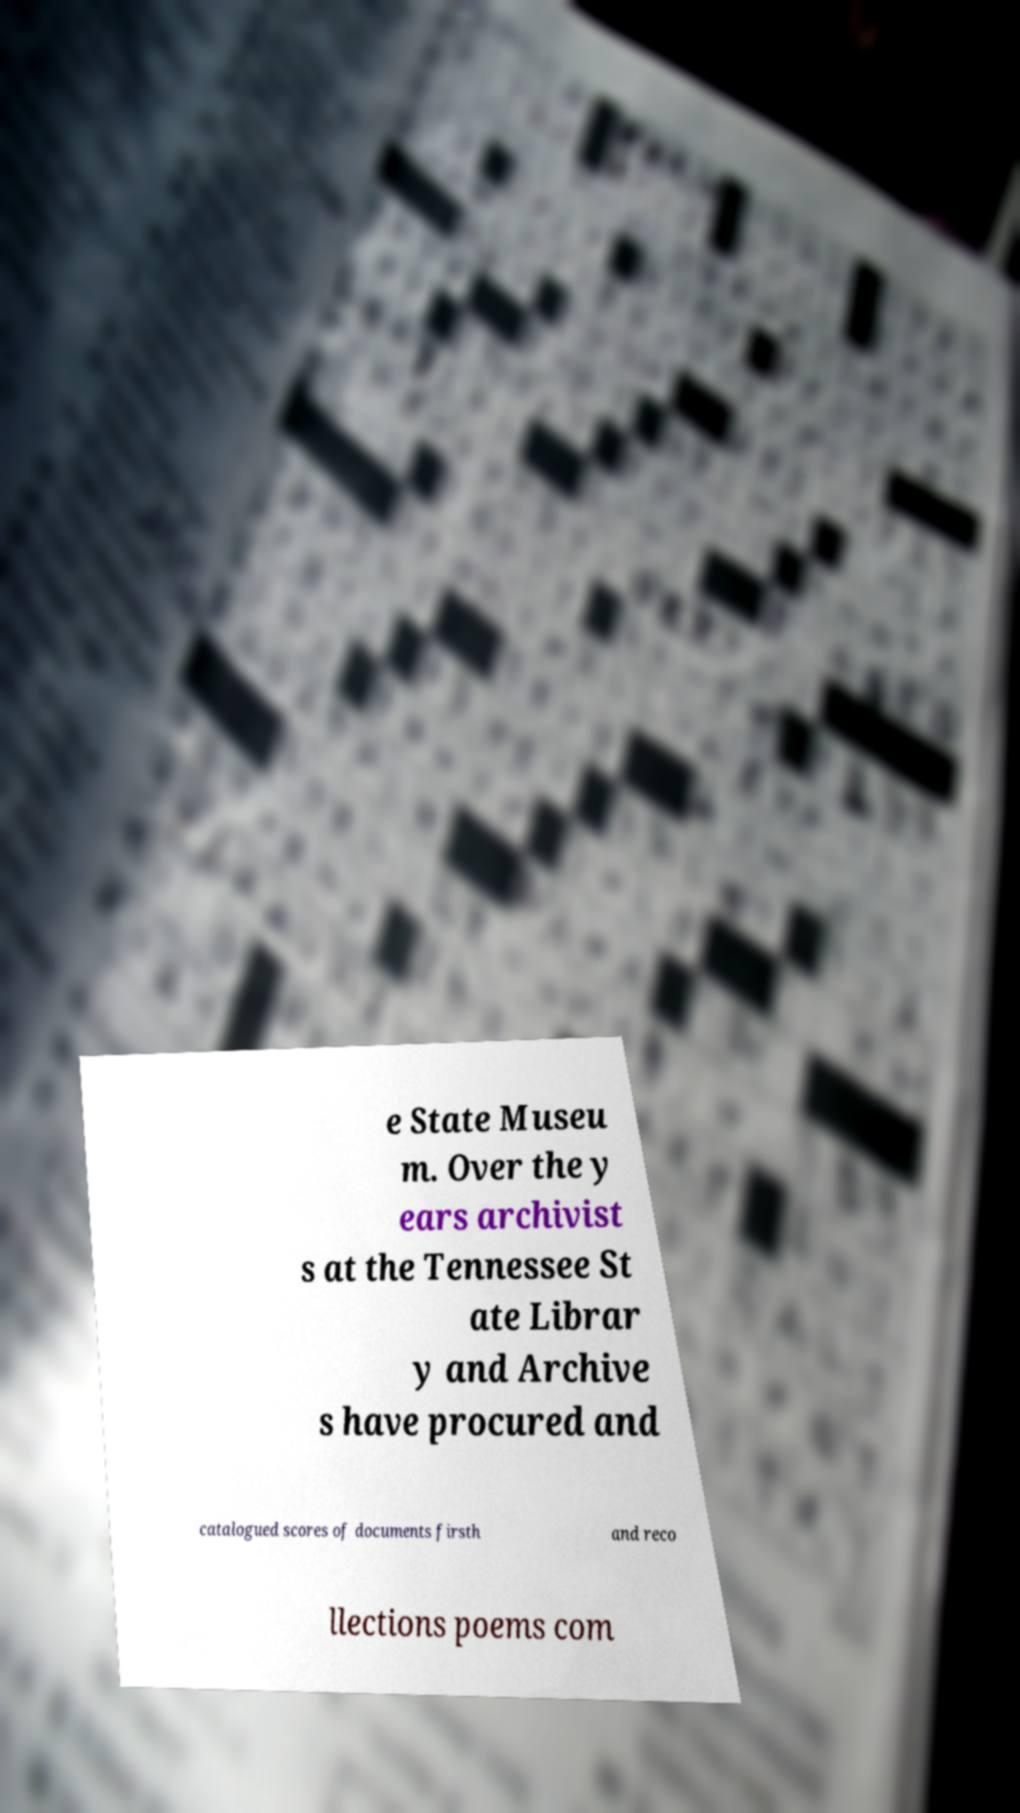Please identify and transcribe the text found in this image. e State Museu m. Over the y ears archivist s at the Tennessee St ate Librar y and Archive s have procured and catalogued scores of documents firsth and reco llections poems com 